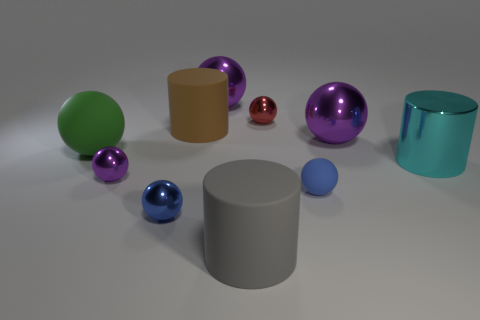How many purple spheres must be subtracted to get 1 purple spheres? 2 Subtract all matte cylinders. How many cylinders are left? 1 Subtract all purple blocks. How many blue spheres are left? 2 Subtract all cylinders. How many objects are left? 7 Subtract 1 balls. How many balls are left? 6 Subtract all brown cylinders. How many cylinders are left? 2 Add 8 large gray matte cylinders. How many large gray matte cylinders exist? 9 Subtract 0 red cubes. How many objects are left? 10 Subtract all brown cylinders. Subtract all purple cubes. How many cylinders are left? 2 Subtract all big cyan metal objects. Subtract all big brown objects. How many objects are left? 8 